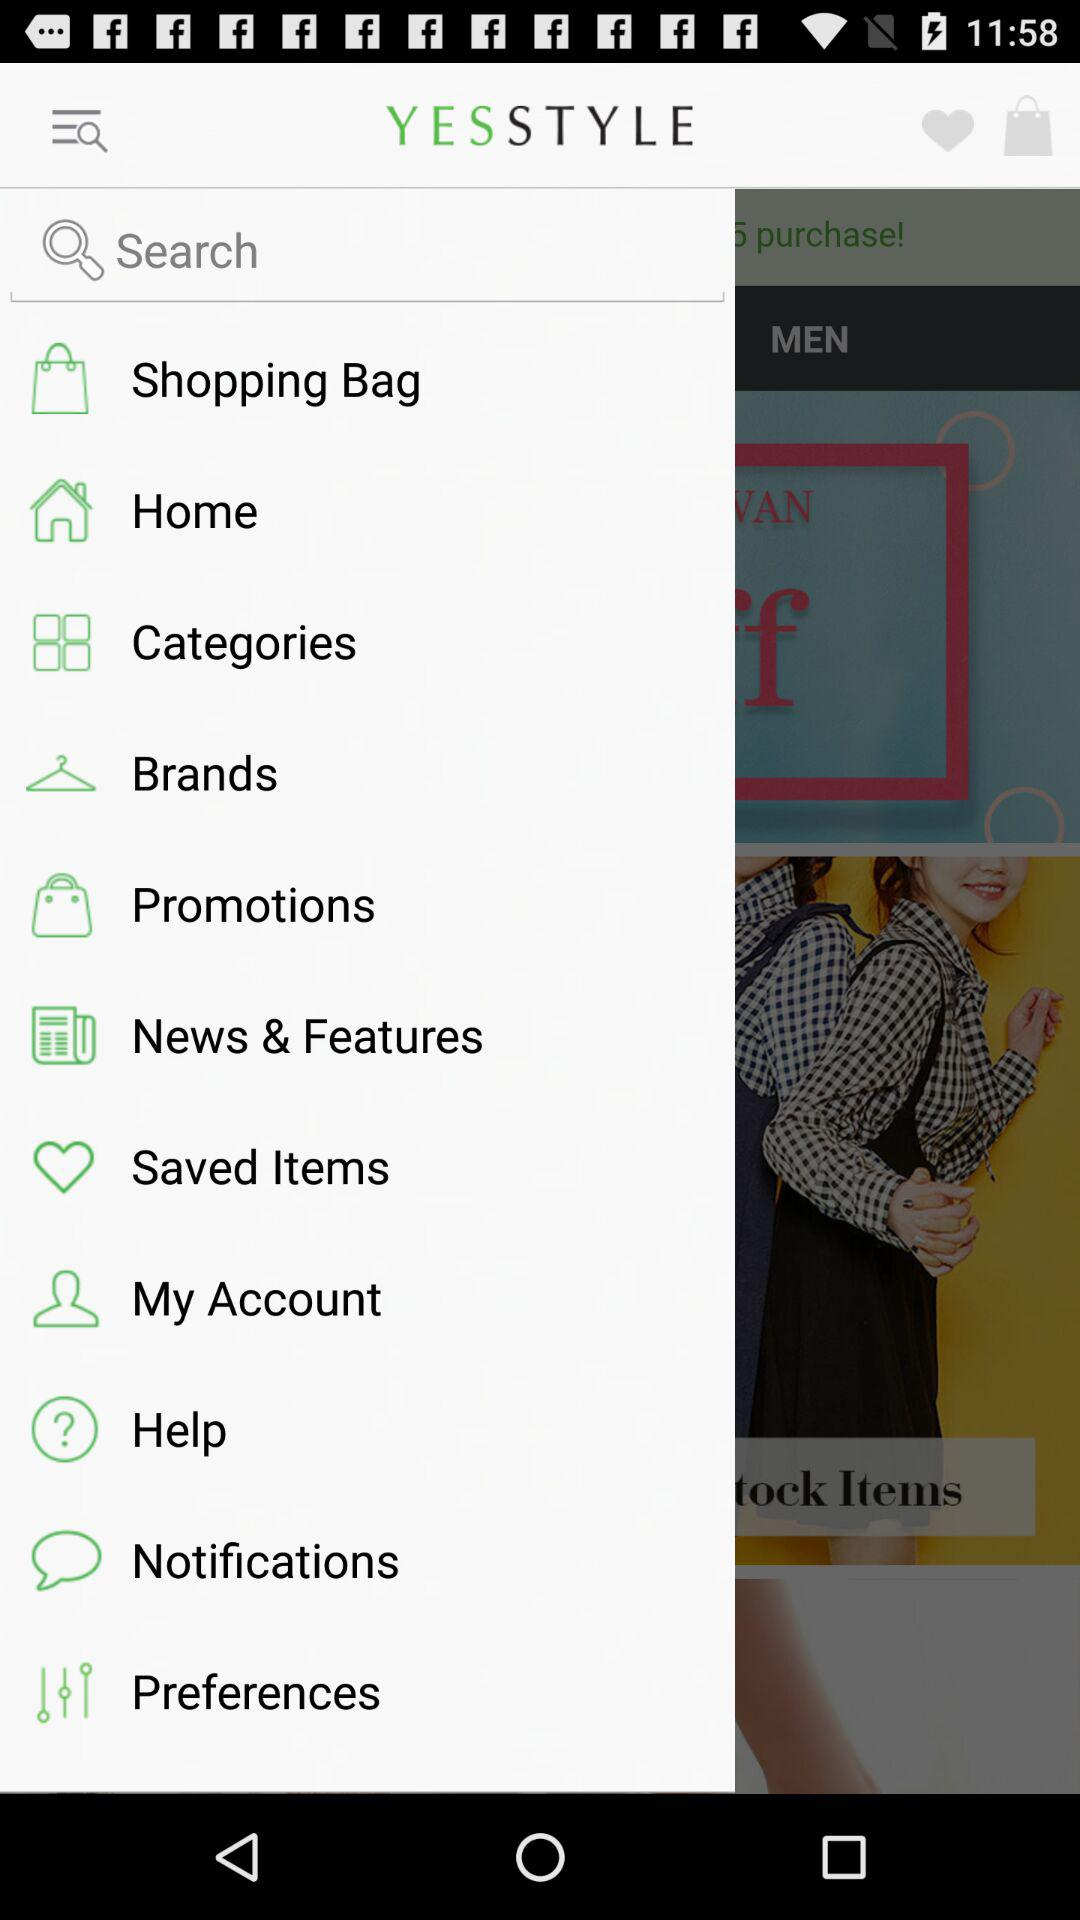When was the last notification made?
When the provided information is insufficient, respond with <no answer>. <no answer> 